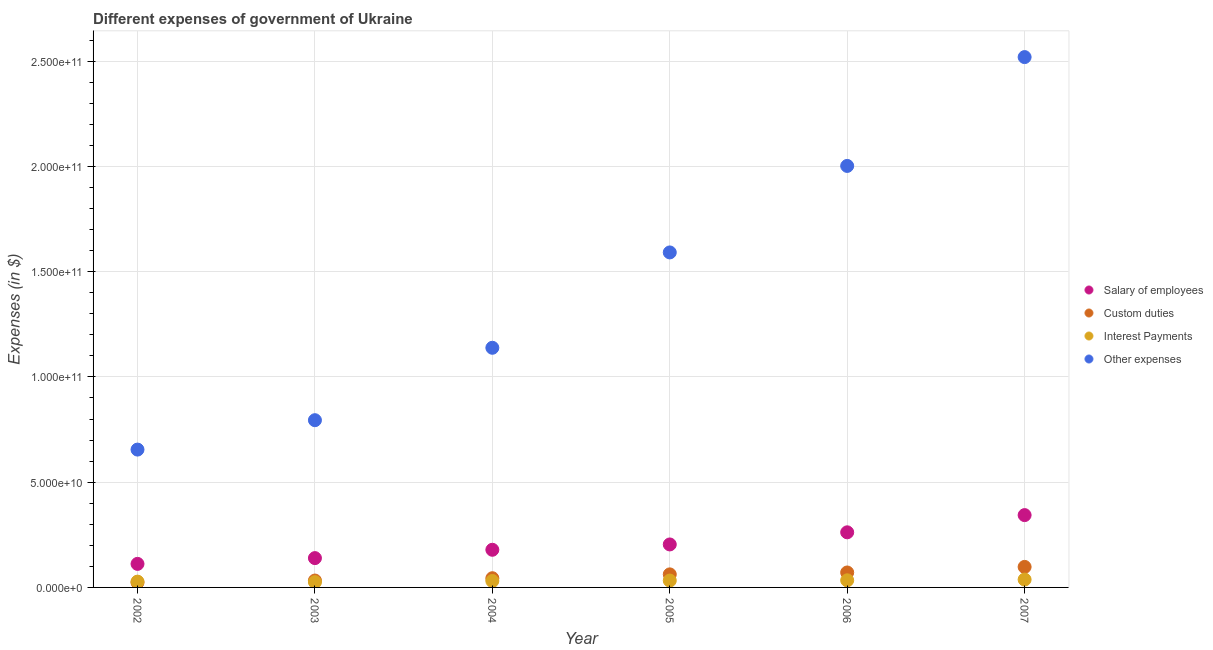Is the number of dotlines equal to the number of legend labels?
Provide a succinct answer. Yes. What is the amount spent on interest payments in 2005?
Offer a terse response. 3.27e+09. Across all years, what is the maximum amount spent on custom duties?
Offer a terse response. 9.74e+09. Across all years, what is the minimum amount spent on custom duties?
Your response must be concise. 2.36e+09. In which year was the amount spent on other expenses maximum?
Your answer should be compact. 2007. What is the total amount spent on salary of employees in the graph?
Provide a succinct answer. 1.24e+11. What is the difference between the amount spent on salary of employees in 2003 and that in 2005?
Give a very brief answer. -6.49e+09. What is the difference between the amount spent on other expenses in 2002 and the amount spent on custom duties in 2005?
Offer a terse response. 5.93e+1. What is the average amount spent on other expenses per year?
Your answer should be very brief. 1.45e+11. In the year 2006, what is the difference between the amount spent on interest payments and amount spent on other expenses?
Ensure brevity in your answer.  -1.97e+11. In how many years, is the amount spent on custom duties greater than 230000000000 $?
Your response must be concise. 0. What is the ratio of the amount spent on interest payments in 2004 to that in 2005?
Make the answer very short. 0.94. What is the difference between the highest and the second highest amount spent on other expenses?
Ensure brevity in your answer.  5.17e+1. What is the difference between the highest and the lowest amount spent on other expenses?
Provide a succinct answer. 1.86e+11. In how many years, is the amount spent on salary of employees greater than the average amount spent on salary of employees taken over all years?
Your answer should be compact. 2. Is the sum of the amount spent on interest payments in 2004 and 2007 greater than the maximum amount spent on custom duties across all years?
Keep it short and to the point. No. Is it the case that in every year, the sum of the amount spent on salary of employees and amount spent on custom duties is greater than the amount spent on interest payments?
Ensure brevity in your answer.  Yes. How many dotlines are there?
Provide a succinct answer. 4. How many years are there in the graph?
Provide a succinct answer. 6. Are the values on the major ticks of Y-axis written in scientific E-notation?
Provide a short and direct response. Yes. Does the graph contain grids?
Your answer should be very brief. Yes. Where does the legend appear in the graph?
Your response must be concise. Center right. How many legend labels are there?
Provide a short and direct response. 4. How are the legend labels stacked?
Your answer should be very brief. Vertical. What is the title of the graph?
Your response must be concise. Different expenses of government of Ukraine. What is the label or title of the Y-axis?
Keep it short and to the point. Expenses (in $). What is the Expenses (in $) of Salary of employees in 2002?
Give a very brief answer. 1.12e+1. What is the Expenses (in $) in Custom duties in 2002?
Provide a succinct answer. 2.36e+09. What is the Expenses (in $) in Interest Payments in 2002?
Your response must be concise. 2.75e+09. What is the Expenses (in $) in Other expenses in 2002?
Your answer should be compact. 6.55e+1. What is the Expenses (in $) in Salary of employees in 2003?
Your response must be concise. 1.39e+1. What is the Expenses (in $) of Custom duties in 2003?
Offer a very short reply. 3.27e+09. What is the Expenses (in $) in Interest Payments in 2003?
Ensure brevity in your answer.  2.52e+09. What is the Expenses (in $) of Other expenses in 2003?
Offer a very short reply. 7.94e+1. What is the Expenses (in $) in Salary of employees in 2004?
Make the answer very short. 1.79e+1. What is the Expenses (in $) in Custom duties in 2004?
Offer a very short reply. 4.37e+09. What is the Expenses (in $) of Interest Payments in 2004?
Your answer should be compact. 3.05e+09. What is the Expenses (in $) in Other expenses in 2004?
Give a very brief answer. 1.14e+11. What is the Expenses (in $) in Salary of employees in 2005?
Provide a succinct answer. 2.04e+1. What is the Expenses (in $) of Custom duties in 2005?
Keep it short and to the point. 6.20e+09. What is the Expenses (in $) in Interest Payments in 2005?
Make the answer very short. 3.27e+09. What is the Expenses (in $) of Other expenses in 2005?
Offer a terse response. 1.59e+11. What is the Expenses (in $) in Salary of employees in 2006?
Give a very brief answer. 2.62e+1. What is the Expenses (in $) in Custom duties in 2006?
Your response must be concise. 7.10e+09. What is the Expenses (in $) of Interest Payments in 2006?
Offer a very short reply. 3.38e+09. What is the Expenses (in $) in Other expenses in 2006?
Keep it short and to the point. 2.00e+11. What is the Expenses (in $) of Salary of employees in 2007?
Keep it short and to the point. 3.44e+1. What is the Expenses (in $) in Custom duties in 2007?
Your answer should be very brief. 9.74e+09. What is the Expenses (in $) in Interest Payments in 2007?
Your answer should be very brief. 3.74e+09. What is the Expenses (in $) in Other expenses in 2007?
Make the answer very short. 2.52e+11. Across all years, what is the maximum Expenses (in $) in Salary of employees?
Offer a terse response. 3.44e+1. Across all years, what is the maximum Expenses (in $) in Custom duties?
Provide a succinct answer. 9.74e+09. Across all years, what is the maximum Expenses (in $) of Interest Payments?
Provide a succinct answer. 3.74e+09. Across all years, what is the maximum Expenses (in $) of Other expenses?
Make the answer very short. 2.52e+11. Across all years, what is the minimum Expenses (in $) in Salary of employees?
Offer a very short reply. 1.12e+1. Across all years, what is the minimum Expenses (in $) of Custom duties?
Provide a succinct answer. 2.36e+09. Across all years, what is the minimum Expenses (in $) of Interest Payments?
Offer a very short reply. 2.52e+09. Across all years, what is the minimum Expenses (in $) of Other expenses?
Your answer should be compact. 6.55e+1. What is the total Expenses (in $) of Salary of employees in the graph?
Offer a terse response. 1.24e+11. What is the total Expenses (in $) in Custom duties in the graph?
Provide a short and direct response. 3.30e+1. What is the total Expenses (in $) in Interest Payments in the graph?
Provide a short and direct response. 1.87e+1. What is the total Expenses (in $) in Other expenses in the graph?
Offer a very short reply. 8.70e+11. What is the difference between the Expenses (in $) in Salary of employees in 2002 and that in 2003?
Offer a very short reply. -2.74e+09. What is the difference between the Expenses (in $) of Custom duties in 2002 and that in 2003?
Give a very brief answer. -9.14e+08. What is the difference between the Expenses (in $) of Interest Payments in 2002 and that in 2003?
Offer a terse response. 2.30e+08. What is the difference between the Expenses (in $) in Other expenses in 2002 and that in 2003?
Make the answer very short. -1.40e+1. What is the difference between the Expenses (in $) of Salary of employees in 2002 and that in 2004?
Provide a short and direct response. -6.70e+09. What is the difference between the Expenses (in $) of Custom duties in 2002 and that in 2004?
Your response must be concise. -2.02e+09. What is the difference between the Expenses (in $) of Interest Payments in 2002 and that in 2004?
Provide a succinct answer. -3.04e+08. What is the difference between the Expenses (in $) of Other expenses in 2002 and that in 2004?
Make the answer very short. -4.84e+1. What is the difference between the Expenses (in $) in Salary of employees in 2002 and that in 2005?
Give a very brief answer. -9.23e+09. What is the difference between the Expenses (in $) in Custom duties in 2002 and that in 2005?
Make the answer very short. -3.84e+09. What is the difference between the Expenses (in $) in Interest Payments in 2002 and that in 2005?
Your answer should be very brief. -5.15e+08. What is the difference between the Expenses (in $) of Other expenses in 2002 and that in 2005?
Ensure brevity in your answer.  -9.36e+1. What is the difference between the Expenses (in $) in Salary of employees in 2002 and that in 2006?
Keep it short and to the point. -1.50e+1. What is the difference between the Expenses (in $) of Custom duties in 2002 and that in 2006?
Offer a terse response. -4.74e+09. What is the difference between the Expenses (in $) of Interest Payments in 2002 and that in 2006?
Your answer should be very brief. -6.27e+08. What is the difference between the Expenses (in $) of Other expenses in 2002 and that in 2006?
Offer a very short reply. -1.35e+11. What is the difference between the Expenses (in $) of Salary of employees in 2002 and that in 2007?
Give a very brief answer. -2.32e+1. What is the difference between the Expenses (in $) of Custom duties in 2002 and that in 2007?
Your answer should be very brief. -7.39e+09. What is the difference between the Expenses (in $) in Interest Payments in 2002 and that in 2007?
Provide a short and direct response. -9.86e+08. What is the difference between the Expenses (in $) in Other expenses in 2002 and that in 2007?
Ensure brevity in your answer.  -1.86e+11. What is the difference between the Expenses (in $) of Salary of employees in 2003 and that in 2004?
Make the answer very short. -3.96e+09. What is the difference between the Expenses (in $) in Custom duties in 2003 and that in 2004?
Provide a succinct answer. -1.10e+09. What is the difference between the Expenses (in $) in Interest Payments in 2003 and that in 2004?
Your response must be concise. -5.34e+08. What is the difference between the Expenses (in $) in Other expenses in 2003 and that in 2004?
Your answer should be very brief. -3.44e+1. What is the difference between the Expenses (in $) in Salary of employees in 2003 and that in 2005?
Make the answer very short. -6.49e+09. What is the difference between the Expenses (in $) in Custom duties in 2003 and that in 2005?
Offer a terse response. -2.93e+09. What is the difference between the Expenses (in $) of Interest Payments in 2003 and that in 2005?
Ensure brevity in your answer.  -7.46e+08. What is the difference between the Expenses (in $) of Other expenses in 2003 and that in 2005?
Offer a very short reply. -7.97e+1. What is the difference between the Expenses (in $) in Salary of employees in 2003 and that in 2006?
Make the answer very short. -1.23e+1. What is the difference between the Expenses (in $) of Custom duties in 2003 and that in 2006?
Make the answer very short. -3.83e+09. What is the difference between the Expenses (in $) in Interest Payments in 2003 and that in 2006?
Your response must be concise. -8.57e+08. What is the difference between the Expenses (in $) in Other expenses in 2003 and that in 2006?
Provide a short and direct response. -1.21e+11. What is the difference between the Expenses (in $) in Salary of employees in 2003 and that in 2007?
Your answer should be very brief. -2.04e+1. What is the difference between the Expenses (in $) in Custom duties in 2003 and that in 2007?
Your response must be concise. -6.47e+09. What is the difference between the Expenses (in $) of Interest Payments in 2003 and that in 2007?
Make the answer very short. -1.22e+09. What is the difference between the Expenses (in $) in Other expenses in 2003 and that in 2007?
Provide a succinct answer. -1.72e+11. What is the difference between the Expenses (in $) of Salary of employees in 2004 and that in 2005?
Your answer should be compact. -2.53e+09. What is the difference between the Expenses (in $) of Custom duties in 2004 and that in 2005?
Offer a very short reply. -1.83e+09. What is the difference between the Expenses (in $) in Interest Payments in 2004 and that in 2005?
Your answer should be compact. -2.11e+08. What is the difference between the Expenses (in $) in Other expenses in 2004 and that in 2005?
Ensure brevity in your answer.  -4.53e+1. What is the difference between the Expenses (in $) of Salary of employees in 2004 and that in 2006?
Ensure brevity in your answer.  -8.30e+09. What is the difference between the Expenses (in $) of Custom duties in 2004 and that in 2006?
Provide a succinct answer. -2.73e+09. What is the difference between the Expenses (in $) of Interest Payments in 2004 and that in 2006?
Your answer should be very brief. -3.23e+08. What is the difference between the Expenses (in $) of Other expenses in 2004 and that in 2006?
Keep it short and to the point. -8.64e+1. What is the difference between the Expenses (in $) of Salary of employees in 2004 and that in 2007?
Provide a short and direct response. -1.65e+1. What is the difference between the Expenses (in $) of Custom duties in 2004 and that in 2007?
Your answer should be compact. -5.37e+09. What is the difference between the Expenses (in $) of Interest Payments in 2004 and that in 2007?
Keep it short and to the point. -6.82e+08. What is the difference between the Expenses (in $) of Other expenses in 2004 and that in 2007?
Ensure brevity in your answer.  -1.38e+11. What is the difference between the Expenses (in $) in Salary of employees in 2005 and that in 2006?
Your answer should be compact. -5.76e+09. What is the difference between the Expenses (in $) in Custom duties in 2005 and that in 2006?
Your response must be concise. -9.02e+08. What is the difference between the Expenses (in $) of Interest Payments in 2005 and that in 2006?
Give a very brief answer. -1.12e+08. What is the difference between the Expenses (in $) of Other expenses in 2005 and that in 2006?
Make the answer very short. -4.11e+1. What is the difference between the Expenses (in $) in Salary of employees in 2005 and that in 2007?
Ensure brevity in your answer.  -1.39e+1. What is the difference between the Expenses (in $) in Custom duties in 2005 and that in 2007?
Offer a terse response. -3.54e+09. What is the difference between the Expenses (in $) of Interest Payments in 2005 and that in 2007?
Offer a very short reply. -4.70e+08. What is the difference between the Expenses (in $) of Other expenses in 2005 and that in 2007?
Your answer should be very brief. -9.28e+1. What is the difference between the Expenses (in $) in Salary of employees in 2006 and that in 2007?
Provide a succinct answer. -8.18e+09. What is the difference between the Expenses (in $) in Custom duties in 2006 and that in 2007?
Make the answer very short. -2.64e+09. What is the difference between the Expenses (in $) of Interest Payments in 2006 and that in 2007?
Ensure brevity in your answer.  -3.59e+08. What is the difference between the Expenses (in $) in Other expenses in 2006 and that in 2007?
Your answer should be compact. -5.17e+1. What is the difference between the Expenses (in $) in Salary of employees in 2002 and the Expenses (in $) in Custom duties in 2003?
Give a very brief answer. 7.91e+09. What is the difference between the Expenses (in $) in Salary of employees in 2002 and the Expenses (in $) in Interest Payments in 2003?
Ensure brevity in your answer.  8.66e+09. What is the difference between the Expenses (in $) in Salary of employees in 2002 and the Expenses (in $) in Other expenses in 2003?
Offer a terse response. -6.83e+1. What is the difference between the Expenses (in $) of Custom duties in 2002 and the Expenses (in $) of Interest Payments in 2003?
Give a very brief answer. -1.62e+08. What is the difference between the Expenses (in $) of Custom duties in 2002 and the Expenses (in $) of Other expenses in 2003?
Your answer should be compact. -7.71e+1. What is the difference between the Expenses (in $) in Interest Payments in 2002 and the Expenses (in $) in Other expenses in 2003?
Keep it short and to the point. -7.67e+1. What is the difference between the Expenses (in $) in Salary of employees in 2002 and the Expenses (in $) in Custom duties in 2004?
Provide a short and direct response. 6.81e+09. What is the difference between the Expenses (in $) in Salary of employees in 2002 and the Expenses (in $) in Interest Payments in 2004?
Provide a short and direct response. 8.13e+09. What is the difference between the Expenses (in $) of Salary of employees in 2002 and the Expenses (in $) of Other expenses in 2004?
Offer a terse response. -1.03e+11. What is the difference between the Expenses (in $) in Custom duties in 2002 and the Expenses (in $) in Interest Payments in 2004?
Give a very brief answer. -6.97e+08. What is the difference between the Expenses (in $) in Custom duties in 2002 and the Expenses (in $) in Other expenses in 2004?
Offer a very short reply. -1.11e+11. What is the difference between the Expenses (in $) in Interest Payments in 2002 and the Expenses (in $) in Other expenses in 2004?
Provide a succinct answer. -1.11e+11. What is the difference between the Expenses (in $) of Salary of employees in 2002 and the Expenses (in $) of Custom duties in 2005?
Your answer should be compact. 4.98e+09. What is the difference between the Expenses (in $) of Salary of employees in 2002 and the Expenses (in $) of Interest Payments in 2005?
Offer a terse response. 7.92e+09. What is the difference between the Expenses (in $) in Salary of employees in 2002 and the Expenses (in $) in Other expenses in 2005?
Offer a terse response. -1.48e+11. What is the difference between the Expenses (in $) in Custom duties in 2002 and the Expenses (in $) in Interest Payments in 2005?
Make the answer very short. -9.08e+08. What is the difference between the Expenses (in $) in Custom duties in 2002 and the Expenses (in $) in Other expenses in 2005?
Your answer should be very brief. -1.57e+11. What is the difference between the Expenses (in $) in Interest Payments in 2002 and the Expenses (in $) in Other expenses in 2005?
Your answer should be very brief. -1.56e+11. What is the difference between the Expenses (in $) of Salary of employees in 2002 and the Expenses (in $) of Custom duties in 2006?
Ensure brevity in your answer.  4.08e+09. What is the difference between the Expenses (in $) in Salary of employees in 2002 and the Expenses (in $) in Interest Payments in 2006?
Keep it short and to the point. 7.81e+09. What is the difference between the Expenses (in $) of Salary of employees in 2002 and the Expenses (in $) of Other expenses in 2006?
Offer a terse response. -1.89e+11. What is the difference between the Expenses (in $) in Custom duties in 2002 and the Expenses (in $) in Interest Payments in 2006?
Keep it short and to the point. -1.02e+09. What is the difference between the Expenses (in $) of Custom duties in 2002 and the Expenses (in $) of Other expenses in 2006?
Keep it short and to the point. -1.98e+11. What is the difference between the Expenses (in $) of Interest Payments in 2002 and the Expenses (in $) of Other expenses in 2006?
Offer a terse response. -1.97e+11. What is the difference between the Expenses (in $) in Salary of employees in 2002 and the Expenses (in $) in Custom duties in 2007?
Your answer should be very brief. 1.44e+09. What is the difference between the Expenses (in $) of Salary of employees in 2002 and the Expenses (in $) of Interest Payments in 2007?
Give a very brief answer. 7.45e+09. What is the difference between the Expenses (in $) in Salary of employees in 2002 and the Expenses (in $) in Other expenses in 2007?
Your response must be concise. -2.41e+11. What is the difference between the Expenses (in $) of Custom duties in 2002 and the Expenses (in $) of Interest Payments in 2007?
Provide a succinct answer. -1.38e+09. What is the difference between the Expenses (in $) of Custom duties in 2002 and the Expenses (in $) of Other expenses in 2007?
Ensure brevity in your answer.  -2.50e+11. What is the difference between the Expenses (in $) in Interest Payments in 2002 and the Expenses (in $) in Other expenses in 2007?
Give a very brief answer. -2.49e+11. What is the difference between the Expenses (in $) of Salary of employees in 2003 and the Expenses (in $) of Custom duties in 2004?
Your response must be concise. 9.55e+09. What is the difference between the Expenses (in $) of Salary of employees in 2003 and the Expenses (in $) of Interest Payments in 2004?
Make the answer very short. 1.09e+1. What is the difference between the Expenses (in $) in Salary of employees in 2003 and the Expenses (in $) in Other expenses in 2004?
Keep it short and to the point. -9.99e+1. What is the difference between the Expenses (in $) in Custom duties in 2003 and the Expenses (in $) in Interest Payments in 2004?
Your answer should be very brief. 2.17e+08. What is the difference between the Expenses (in $) of Custom duties in 2003 and the Expenses (in $) of Other expenses in 2004?
Your answer should be compact. -1.11e+11. What is the difference between the Expenses (in $) of Interest Payments in 2003 and the Expenses (in $) of Other expenses in 2004?
Your answer should be very brief. -1.11e+11. What is the difference between the Expenses (in $) in Salary of employees in 2003 and the Expenses (in $) in Custom duties in 2005?
Your response must be concise. 7.73e+09. What is the difference between the Expenses (in $) in Salary of employees in 2003 and the Expenses (in $) in Interest Payments in 2005?
Provide a succinct answer. 1.07e+1. What is the difference between the Expenses (in $) of Salary of employees in 2003 and the Expenses (in $) of Other expenses in 2005?
Your response must be concise. -1.45e+11. What is the difference between the Expenses (in $) in Custom duties in 2003 and the Expenses (in $) in Interest Payments in 2005?
Offer a very short reply. 5.59e+06. What is the difference between the Expenses (in $) of Custom duties in 2003 and the Expenses (in $) of Other expenses in 2005?
Offer a very short reply. -1.56e+11. What is the difference between the Expenses (in $) in Interest Payments in 2003 and the Expenses (in $) in Other expenses in 2005?
Make the answer very short. -1.57e+11. What is the difference between the Expenses (in $) of Salary of employees in 2003 and the Expenses (in $) of Custom duties in 2006?
Your response must be concise. 6.83e+09. What is the difference between the Expenses (in $) in Salary of employees in 2003 and the Expenses (in $) in Interest Payments in 2006?
Your response must be concise. 1.05e+1. What is the difference between the Expenses (in $) in Salary of employees in 2003 and the Expenses (in $) in Other expenses in 2006?
Provide a short and direct response. -1.86e+11. What is the difference between the Expenses (in $) of Custom duties in 2003 and the Expenses (in $) of Interest Payments in 2006?
Your answer should be compact. -1.06e+08. What is the difference between the Expenses (in $) in Custom duties in 2003 and the Expenses (in $) in Other expenses in 2006?
Your answer should be very brief. -1.97e+11. What is the difference between the Expenses (in $) of Interest Payments in 2003 and the Expenses (in $) of Other expenses in 2006?
Your answer should be compact. -1.98e+11. What is the difference between the Expenses (in $) in Salary of employees in 2003 and the Expenses (in $) in Custom duties in 2007?
Provide a short and direct response. 4.18e+09. What is the difference between the Expenses (in $) in Salary of employees in 2003 and the Expenses (in $) in Interest Payments in 2007?
Offer a terse response. 1.02e+1. What is the difference between the Expenses (in $) of Salary of employees in 2003 and the Expenses (in $) of Other expenses in 2007?
Give a very brief answer. -2.38e+11. What is the difference between the Expenses (in $) in Custom duties in 2003 and the Expenses (in $) in Interest Payments in 2007?
Keep it short and to the point. -4.65e+08. What is the difference between the Expenses (in $) of Custom duties in 2003 and the Expenses (in $) of Other expenses in 2007?
Your answer should be very brief. -2.49e+11. What is the difference between the Expenses (in $) in Interest Payments in 2003 and the Expenses (in $) in Other expenses in 2007?
Offer a terse response. -2.49e+11. What is the difference between the Expenses (in $) in Salary of employees in 2004 and the Expenses (in $) in Custom duties in 2005?
Keep it short and to the point. 1.17e+1. What is the difference between the Expenses (in $) of Salary of employees in 2004 and the Expenses (in $) of Interest Payments in 2005?
Give a very brief answer. 1.46e+1. What is the difference between the Expenses (in $) of Salary of employees in 2004 and the Expenses (in $) of Other expenses in 2005?
Provide a short and direct response. -1.41e+11. What is the difference between the Expenses (in $) of Custom duties in 2004 and the Expenses (in $) of Interest Payments in 2005?
Your response must be concise. 1.11e+09. What is the difference between the Expenses (in $) in Custom duties in 2004 and the Expenses (in $) in Other expenses in 2005?
Provide a succinct answer. -1.55e+11. What is the difference between the Expenses (in $) of Interest Payments in 2004 and the Expenses (in $) of Other expenses in 2005?
Offer a terse response. -1.56e+11. What is the difference between the Expenses (in $) of Salary of employees in 2004 and the Expenses (in $) of Custom duties in 2006?
Keep it short and to the point. 1.08e+1. What is the difference between the Expenses (in $) of Salary of employees in 2004 and the Expenses (in $) of Interest Payments in 2006?
Keep it short and to the point. 1.45e+1. What is the difference between the Expenses (in $) in Salary of employees in 2004 and the Expenses (in $) in Other expenses in 2006?
Provide a short and direct response. -1.82e+11. What is the difference between the Expenses (in $) of Custom duties in 2004 and the Expenses (in $) of Interest Payments in 2006?
Keep it short and to the point. 9.96e+08. What is the difference between the Expenses (in $) of Custom duties in 2004 and the Expenses (in $) of Other expenses in 2006?
Provide a succinct answer. -1.96e+11. What is the difference between the Expenses (in $) of Interest Payments in 2004 and the Expenses (in $) of Other expenses in 2006?
Your answer should be very brief. -1.97e+11. What is the difference between the Expenses (in $) in Salary of employees in 2004 and the Expenses (in $) in Custom duties in 2007?
Offer a terse response. 8.14e+09. What is the difference between the Expenses (in $) of Salary of employees in 2004 and the Expenses (in $) of Interest Payments in 2007?
Offer a very short reply. 1.41e+1. What is the difference between the Expenses (in $) of Salary of employees in 2004 and the Expenses (in $) of Other expenses in 2007?
Give a very brief answer. -2.34e+11. What is the difference between the Expenses (in $) in Custom duties in 2004 and the Expenses (in $) in Interest Payments in 2007?
Ensure brevity in your answer.  6.37e+08. What is the difference between the Expenses (in $) in Custom duties in 2004 and the Expenses (in $) in Other expenses in 2007?
Your answer should be compact. -2.48e+11. What is the difference between the Expenses (in $) in Interest Payments in 2004 and the Expenses (in $) in Other expenses in 2007?
Provide a succinct answer. -2.49e+11. What is the difference between the Expenses (in $) in Salary of employees in 2005 and the Expenses (in $) in Custom duties in 2006?
Your answer should be very brief. 1.33e+1. What is the difference between the Expenses (in $) of Salary of employees in 2005 and the Expenses (in $) of Interest Payments in 2006?
Make the answer very short. 1.70e+1. What is the difference between the Expenses (in $) of Salary of employees in 2005 and the Expenses (in $) of Other expenses in 2006?
Make the answer very short. -1.80e+11. What is the difference between the Expenses (in $) of Custom duties in 2005 and the Expenses (in $) of Interest Payments in 2006?
Make the answer very short. 2.82e+09. What is the difference between the Expenses (in $) of Custom duties in 2005 and the Expenses (in $) of Other expenses in 2006?
Keep it short and to the point. -1.94e+11. What is the difference between the Expenses (in $) of Interest Payments in 2005 and the Expenses (in $) of Other expenses in 2006?
Provide a short and direct response. -1.97e+11. What is the difference between the Expenses (in $) in Salary of employees in 2005 and the Expenses (in $) in Custom duties in 2007?
Ensure brevity in your answer.  1.07e+1. What is the difference between the Expenses (in $) of Salary of employees in 2005 and the Expenses (in $) of Interest Payments in 2007?
Provide a short and direct response. 1.67e+1. What is the difference between the Expenses (in $) of Salary of employees in 2005 and the Expenses (in $) of Other expenses in 2007?
Your answer should be compact. -2.31e+11. What is the difference between the Expenses (in $) of Custom duties in 2005 and the Expenses (in $) of Interest Payments in 2007?
Offer a terse response. 2.46e+09. What is the difference between the Expenses (in $) of Custom duties in 2005 and the Expenses (in $) of Other expenses in 2007?
Provide a succinct answer. -2.46e+11. What is the difference between the Expenses (in $) of Interest Payments in 2005 and the Expenses (in $) of Other expenses in 2007?
Keep it short and to the point. -2.49e+11. What is the difference between the Expenses (in $) of Salary of employees in 2006 and the Expenses (in $) of Custom duties in 2007?
Keep it short and to the point. 1.64e+1. What is the difference between the Expenses (in $) in Salary of employees in 2006 and the Expenses (in $) in Interest Payments in 2007?
Your answer should be very brief. 2.24e+1. What is the difference between the Expenses (in $) of Salary of employees in 2006 and the Expenses (in $) of Other expenses in 2007?
Ensure brevity in your answer.  -2.26e+11. What is the difference between the Expenses (in $) of Custom duties in 2006 and the Expenses (in $) of Interest Payments in 2007?
Provide a succinct answer. 3.37e+09. What is the difference between the Expenses (in $) of Custom duties in 2006 and the Expenses (in $) of Other expenses in 2007?
Make the answer very short. -2.45e+11. What is the difference between the Expenses (in $) in Interest Payments in 2006 and the Expenses (in $) in Other expenses in 2007?
Offer a terse response. -2.49e+11. What is the average Expenses (in $) in Salary of employees per year?
Offer a very short reply. 2.07e+1. What is the average Expenses (in $) of Custom duties per year?
Ensure brevity in your answer.  5.51e+09. What is the average Expenses (in $) in Interest Payments per year?
Your answer should be compact. 3.12e+09. What is the average Expenses (in $) of Other expenses per year?
Your answer should be very brief. 1.45e+11. In the year 2002, what is the difference between the Expenses (in $) of Salary of employees and Expenses (in $) of Custom duties?
Your answer should be very brief. 8.83e+09. In the year 2002, what is the difference between the Expenses (in $) of Salary of employees and Expenses (in $) of Interest Payments?
Offer a very short reply. 8.43e+09. In the year 2002, what is the difference between the Expenses (in $) of Salary of employees and Expenses (in $) of Other expenses?
Your response must be concise. -5.43e+1. In the year 2002, what is the difference between the Expenses (in $) of Custom duties and Expenses (in $) of Interest Payments?
Make the answer very short. -3.93e+08. In the year 2002, what is the difference between the Expenses (in $) of Custom duties and Expenses (in $) of Other expenses?
Provide a succinct answer. -6.31e+1. In the year 2002, what is the difference between the Expenses (in $) in Interest Payments and Expenses (in $) in Other expenses?
Make the answer very short. -6.27e+1. In the year 2003, what is the difference between the Expenses (in $) in Salary of employees and Expenses (in $) in Custom duties?
Your answer should be compact. 1.07e+1. In the year 2003, what is the difference between the Expenses (in $) in Salary of employees and Expenses (in $) in Interest Payments?
Provide a succinct answer. 1.14e+1. In the year 2003, what is the difference between the Expenses (in $) in Salary of employees and Expenses (in $) in Other expenses?
Your response must be concise. -6.55e+1. In the year 2003, what is the difference between the Expenses (in $) in Custom duties and Expenses (in $) in Interest Payments?
Offer a very short reply. 7.51e+08. In the year 2003, what is the difference between the Expenses (in $) of Custom duties and Expenses (in $) of Other expenses?
Provide a short and direct response. -7.62e+1. In the year 2003, what is the difference between the Expenses (in $) of Interest Payments and Expenses (in $) of Other expenses?
Your answer should be compact. -7.69e+1. In the year 2004, what is the difference between the Expenses (in $) of Salary of employees and Expenses (in $) of Custom duties?
Offer a very short reply. 1.35e+1. In the year 2004, what is the difference between the Expenses (in $) in Salary of employees and Expenses (in $) in Interest Payments?
Provide a short and direct response. 1.48e+1. In the year 2004, what is the difference between the Expenses (in $) of Salary of employees and Expenses (in $) of Other expenses?
Ensure brevity in your answer.  -9.60e+1. In the year 2004, what is the difference between the Expenses (in $) of Custom duties and Expenses (in $) of Interest Payments?
Give a very brief answer. 1.32e+09. In the year 2004, what is the difference between the Expenses (in $) of Custom duties and Expenses (in $) of Other expenses?
Ensure brevity in your answer.  -1.09e+11. In the year 2004, what is the difference between the Expenses (in $) in Interest Payments and Expenses (in $) in Other expenses?
Keep it short and to the point. -1.11e+11. In the year 2005, what is the difference between the Expenses (in $) of Salary of employees and Expenses (in $) of Custom duties?
Your answer should be very brief. 1.42e+1. In the year 2005, what is the difference between the Expenses (in $) of Salary of employees and Expenses (in $) of Interest Payments?
Offer a very short reply. 1.72e+1. In the year 2005, what is the difference between the Expenses (in $) of Salary of employees and Expenses (in $) of Other expenses?
Give a very brief answer. -1.39e+11. In the year 2005, what is the difference between the Expenses (in $) of Custom duties and Expenses (in $) of Interest Payments?
Your answer should be very brief. 2.93e+09. In the year 2005, what is the difference between the Expenses (in $) in Custom duties and Expenses (in $) in Other expenses?
Keep it short and to the point. -1.53e+11. In the year 2005, what is the difference between the Expenses (in $) in Interest Payments and Expenses (in $) in Other expenses?
Give a very brief answer. -1.56e+11. In the year 2006, what is the difference between the Expenses (in $) of Salary of employees and Expenses (in $) of Custom duties?
Your response must be concise. 1.91e+1. In the year 2006, what is the difference between the Expenses (in $) in Salary of employees and Expenses (in $) in Interest Payments?
Offer a very short reply. 2.28e+1. In the year 2006, what is the difference between the Expenses (in $) of Salary of employees and Expenses (in $) of Other expenses?
Provide a short and direct response. -1.74e+11. In the year 2006, what is the difference between the Expenses (in $) in Custom duties and Expenses (in $) in Interest Payments?
Offer a terse response. 3.72e+09. In the year 2006, what is the difference between the Expenses (in $) in Custom duties and Expenses (in $) in Other expenses?
Provide a succinct answer. -1.93e+11. In the year 2006, what is the difference between the Expenses (in $) of Interest Payments and Expenses (in $) of Other expenses?
Make the answer very short. -1.97e+11. In the year 2007, what is the difference between the Expenses (in $) of Salary of employees and Expenses (in $) of Custom duties?
Give a very brief answer. 2.46e+1. In the year 2007, what is the difference between the Expenses (in $) in Salary of employees and Expenses (in $) in Interest Payments?
Provide a short and direct response. 3.06e+1. In the year 2007, what is the difference between the Expenses (in $) of Salary of employees and Expenses (in $) of Other expenses?
Provide a succinct answer. -2.18e+11. In the year 2007, what is the difference between the Expenses (in $) of Custom duties and Expenses (in $) of Interest Payments?
Your response must be concise. 6.01e+09. In the year 2007, what is the difference between the Expenses (in $) in Custom duties and Expenses (in $) in Other expenses?
Offer a terse response. -2.42e+11. In the year 2007, what is the difference between the Expenses (in $) in Interest Payments and Expenses (in $) in Other expenses?
Make the answer very short. -2.48e+11. What is the ratio of the Expenses (in $) of Salary of employees in 2002 to that in 2003?
Keep it short and to the point. 0.8. What is the ratio of the Expenses (in $) of Custom duties in 2002 to that in 2003?
Give a very brief answer. 0.72. What is the ratio of the Expenses (in $) of Interest Payments in 2002 to that in 2003?
Offer a very short reply. 1.09. What is the ratio of the Expenses (in $) of Other expenses in 2002 to that in 2003?
Keep it short and to the point. 0.82. What is the ratio of the Expenses (in $) in Salary of employees in 2002 to that in 2004?
Your response must be concise. 0.63. What is the ratio of the Expenses (in $) in Custom duties in 2002 to that in 2004?
Your response must be concise. 0.54. What is the ratio of the Expenses (in $) in Interest Payments in 2002 to that in 2004?
Give a very brief answer. 0.9. What is the ratio of the Expenses (in $) in Other expenses in 2002 to that in 2004?
Your response must be concise. 0.58. What is the ratio of the Expenses (in $) of Salary of employees in 2002 to that in 2005?
Give a very brief answer. 0.55. What is the ratio of the Expenses (in $) in Custom duties in 2002 to that in 2005?
Your response must be concise. 0.38. What is the ratio of the Expenses (in $) in Interest Payments in 2002 to that in 2005?
Provide a succinct answer. 0.84. What is the ratio of the Expenses (in $) in Other expenses in 2002 to that in 2005?
Your answer should be very brief. 0.41. What is the ratio of the Expenses (in $) of Salary of employees in 2002 to that in 2006?
Your answer should be very brief. 0.43. What is the ratio of the Expenses (in $) in Custom duties in 2002 to that in 2006?
Your answer should be compact. 0.33. What is the ratio of the Expenses (in $) of Interest Payments in 2002 to that in 2006?
Offer a very short reply. 0.81. What is the ratio of the Expenses (in $) in Other expenses in 2002 to that in 2006?
Ensure brevity in your answer.  0.33. What is the ratio of the Expenses (in $) in Salary of employees in 2002 to that in 2007?
Your answer should be very brief. 0.33. What is the ratio of the Expenses (in $) in Custom duties in 2002 to that in 2007?
Keep it short and to the point. 0.24. What is the ratio of the Expenses (in $) in Interest Payments in 2002 to that in 2007?
Your answer should be compact. 0.74. What is the ratio of the Expenses (in $) in Other expenses in 2002 to that in 2007?
Your answer should be compact. 0.26. What is the ratio of the Expenses (in $) in Salary of employees in 2003 to that in 2004?
Your response must be concise. 0.78. What is the ratio of the Expenses (in $) of Custom duties in 2003 to that in 2004?
Offer a very short reply. 0.75. What is the ratio of the Expenses (in $) of Interest Payments in 2003 to that in 2004?
Provide a short and direct response. 0.82. What is the ratio of the Expenses (in $) in Other expenses in 2003 to that in 2004?
Your answer should be compact. 0.7. What is the ratio of the Expenses (in $) of Salary of employees in 2003 to that in 2005?
Provide a short and direct response. 0.68. What is the ratio of the Expenses (in $) of Custom duties in 2003 to that in 2005?
Provide a short and direct response. 0.53. What is the ratio of the Expenses (in $) in Interest Payments in 2003 to that in 2005?
Your response must be concise. 0.77. What is the ratio of the Expenses (in $) in Other expenses in 2003 to that in 2005?
Your answer should be very brief. 0.5. What is the ratio of the Expenses (in $) of Salary of employees in 2003 to that in 2006?
Give a very brief answer. 0.53. What is the ratio of the Expenses (in $) of Custom duties in 2003 to that in 2006?
Give a very brief answer. 0.46. What is the ratio of the Expenses (in $) of Interest Payments in 2003 to that in 2006?
Provide a short and direct response. 0.75. What is the ratio of the Expenses (in $) in Other expenses in 2003 to that in 2006?
Offer a terse response. 0.4. What is the ratio of the Expenses (in $) in Salary of employees in 2003 to that in 2007?
Your response must be concise. 0.41. What is the ratio of the Expenses (in $) in Custom duties in 2003 to that in 2007?
Offer a very short reply. 0.34. What is the ratio of the Expenses (in $) in Interest Payments in 2003 to that in 2007?
Ensure brevity in your answer.  0.67. What is the ratio of the Expenses (in $) of Other expenses in 2003 to that in 2007?
Your answer should be compact. 0.32. What is the ratio of the Expenses (in $) in Salary of employees in 2004 to that in 2005?
Provide a short and direct response. 0.88. What is the ratio of the Expenses (in $) of Custom duties in 2004 to that in 2005?
Your answer should be very brief. 0.71. What is the ratio of the Expenses (in $) in Interest Payments in 2004 to that in 2005?
Offer a very short reply. 0.94. What is the ratio of the Expenses (in $) of Other expenses in 2004 to that in 2005?
Make the answer very short. 0.72. What is the ratio of the Expenses (in $) in Salary of employees in 2004 to that in 2006?
Your response must be concise. 0.68. What is the ratio of the Expenses (in $) in Custom duties in 2004 to that in 2006?
Keep it short and to the point. 0.62. What is the ratio of the Expenses (in $) in Interest Payments in 2004 to that in 2006?
Provide a short and direct response. 0.9. What is the ratio of the Expenses (in $) in Other expenses in 2004 to that in 2006?
Offer a terse response. 0.57. What is the ratio of the Expenses (in $) in Salary of employees in 2004 to that in 2007?
Your answer should be very brief. 0.52. What is the ratio of the Expenses (in $) of Custom duties in 2004 to that in 2007?
Your answer should be very brief. 0.45. What is the ratio of the Expenses (in $) in Interest Payments in 2004 to that in 2007?
Offer a terse response. 0.82. What is the ratio of the Expenses (in $) of Other expenses in 2004 to that in 2007?
Offer a very short reply. 0.45. What is the ratio of the Expenses (in $) of Salary of employees in 2005 to that in 2006?
Your answer should be compact. 0.78. What is the ratio of the Expenses (in $) of Custom duties in 2005 to that in 2006?
Give a very brief answer. 0.87. What is the ratio of the Expenses (in $) in Interest Payments in 2005 to that in 2006?
Your answer should be compact. 0.97. What is the ratio of the Expenses (in $) of Other expenses in 2005 to that in 2006?
Your response must be concise. 0.79. What is the ratio of the Expenses (in $) in Salary of employees in 2005 to that in 2007?
Offer a very short reply. 0.59. What is the ratio of the Expenses (in $) in Custom duties in 2005 to that in 2007?
Offer a terse response. 0.64. What is the ratio of the Expenses (in $) in Interest Payments in 2005 to that in 2007?
Your response must be concise. 0.87. What is the ratio of the Expenses (in $) of Other expenses in 2005 to that in 2007?
Ensure brevity in your answer.  0.63. What is the ratio of the Expenses (in $) in Salary of employees in 2006 to that in 2007?
Give a very brief answer. 0.76. What is the ratio of the Expenses (in $) in Custom duties in 2006 to that in 2007?
Your response must be concise. 0.73. What is the ratio of the Expenses (in $) in Interest Payments in 2006 to that in 2007?
Make the answer very short. 0.9. What is the ratio of the Expenses (in $) in Other expenses in 2006 to that in 2007?
Keep it short and to the point. 0.79. What is the difference between the highest and the second highest Expenses (in $) of Salary of employees?
Offer a very short reply. 8.18e+09. What is the difference between the highest and the second highest Expenses (in $) in Custom duties?
Offer a very short reply. 2.64e+09. What is the difference between the highest and the second highest Expenses (in $) of Interest Payments?
Offer a terse response. 3.59e+08. What is the difference between the highest and the second highest Expenses (in $) of Other expenses?
Your response must be concise. 5.17e+1. What is the difference between the highest and the lowest Expenses (in $) in Salary of employees?
Offer a very short reply. 2.32e+1. What is the difference between the highest and the lowest Expenses (in $) in Custom duties?
Provide a succinct answer. 7.39e+09. What is the difference between the highest and the lowest Expenses (in $) in Interest Payments?
Keep it short and to the point. 1.22e+09. What is the difference between the highest and the lowest Expenses (in $) of Other expenses?
Provide a short and direct response. 1.86e+11. 